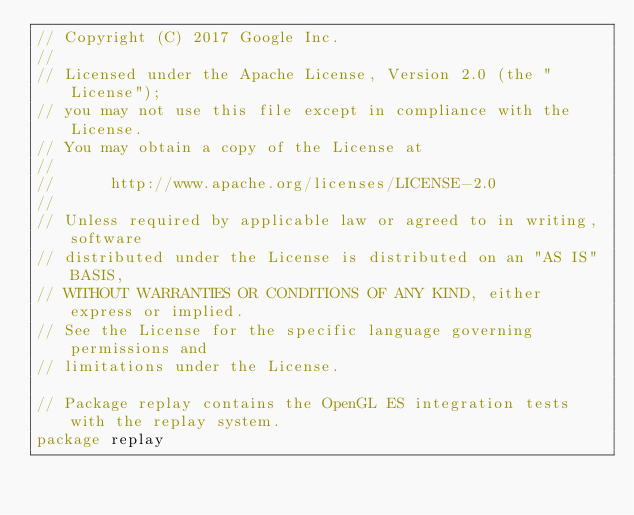<code> <loc_0><loc_0><loc_500><loc_500><_Go_>// Copyright (C) 2017 Google Inc.
//
// Licensed under the Apache License, Version 2.0 (the "License");
// you may not use this file except in compliance with the License.
// You may obtain a copy of the License at
//
//      http://www.apache.org/licenses/LICENSE-2.0
//
// Unless required by applicable law or agreed to in writing, software
// distributed under the License is distributed on an "AS IS" BASIS,
// WITHOUT WARRANTIES OR CONDITIONS OF ANY KIND, either express or implied.
// See the License for the specific language governing permissions and
// limitations under the License.

// Package replay contains the OpenGL ES integration tests with the replay system.
package replay
</code> 